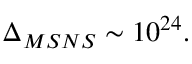<formula> <loc_0><loc_0><loc_500><loc_500>\Delta _ { M S N S } \sim 1 0 ^ { 2 4 } .</formula> 